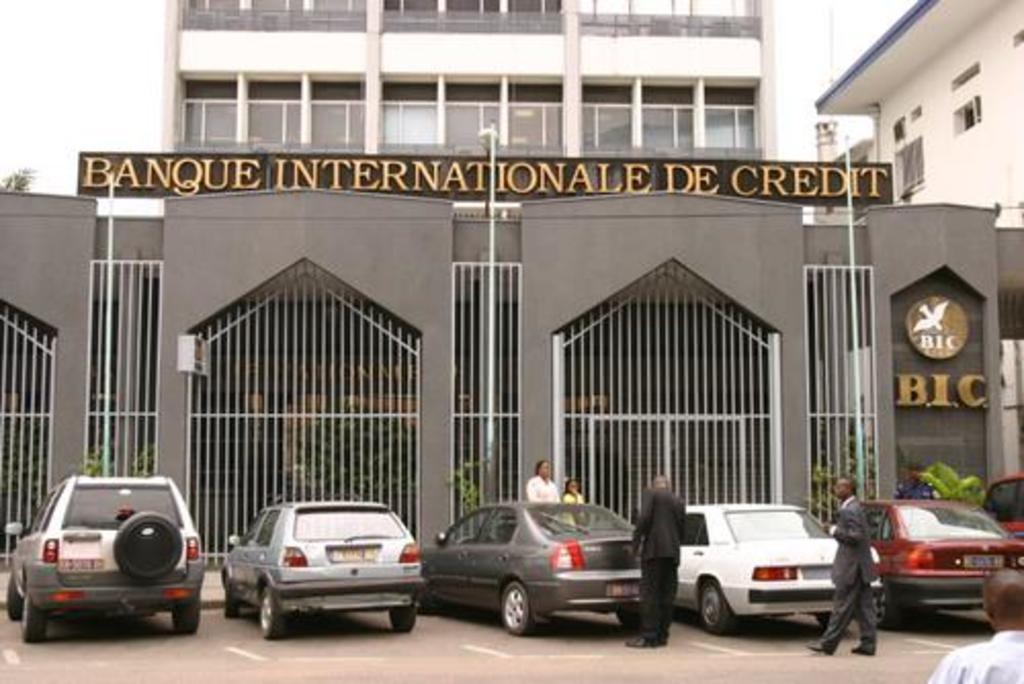Describe this image in one or two sentences. This picture is clicked outside. In the foreground we can see the group of people and we can see the group of cars parked on the ground. In the background we can see the sky, buildings, metal rods, green leaves and we can see the text on the board and we can see the text is attached to the wall of the building and we can see the lamp posts and many other objects. 